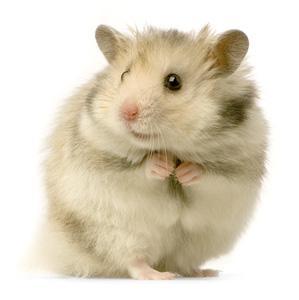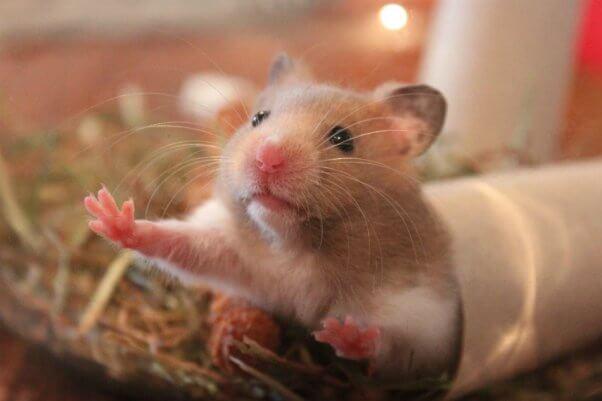The first image is the image on the left, the second image is the image on the right. For the images displayed, is the sentence "At least one hamster is sitting in someone's hand." factually correct? Answer yes or no. No. 